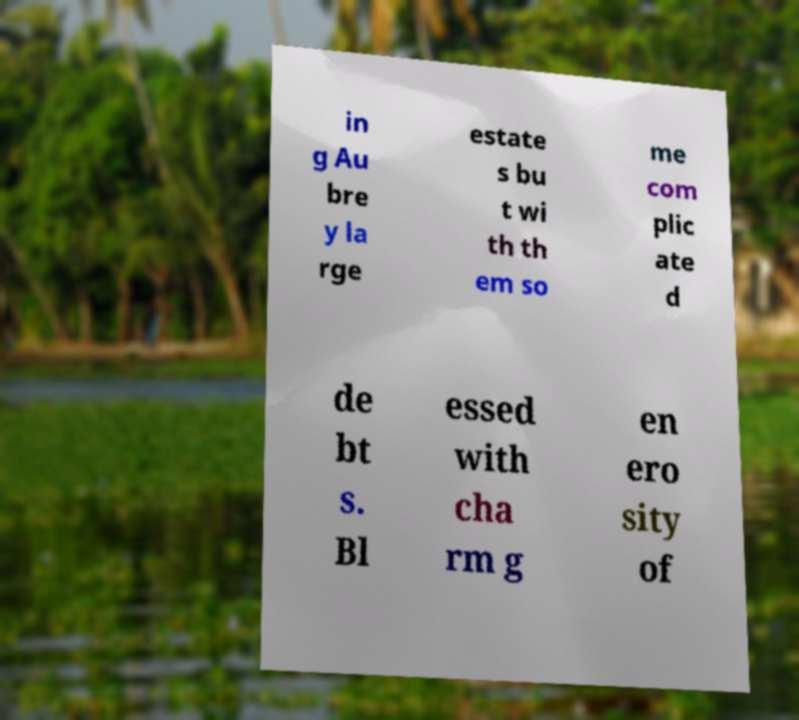I need the written content from this picture converted into text. Can you do that? in g Au bre y la rge estate s bu t wi th th em so me com plic ate d de bt s. Bl essed with cha rm g en ero sity of 